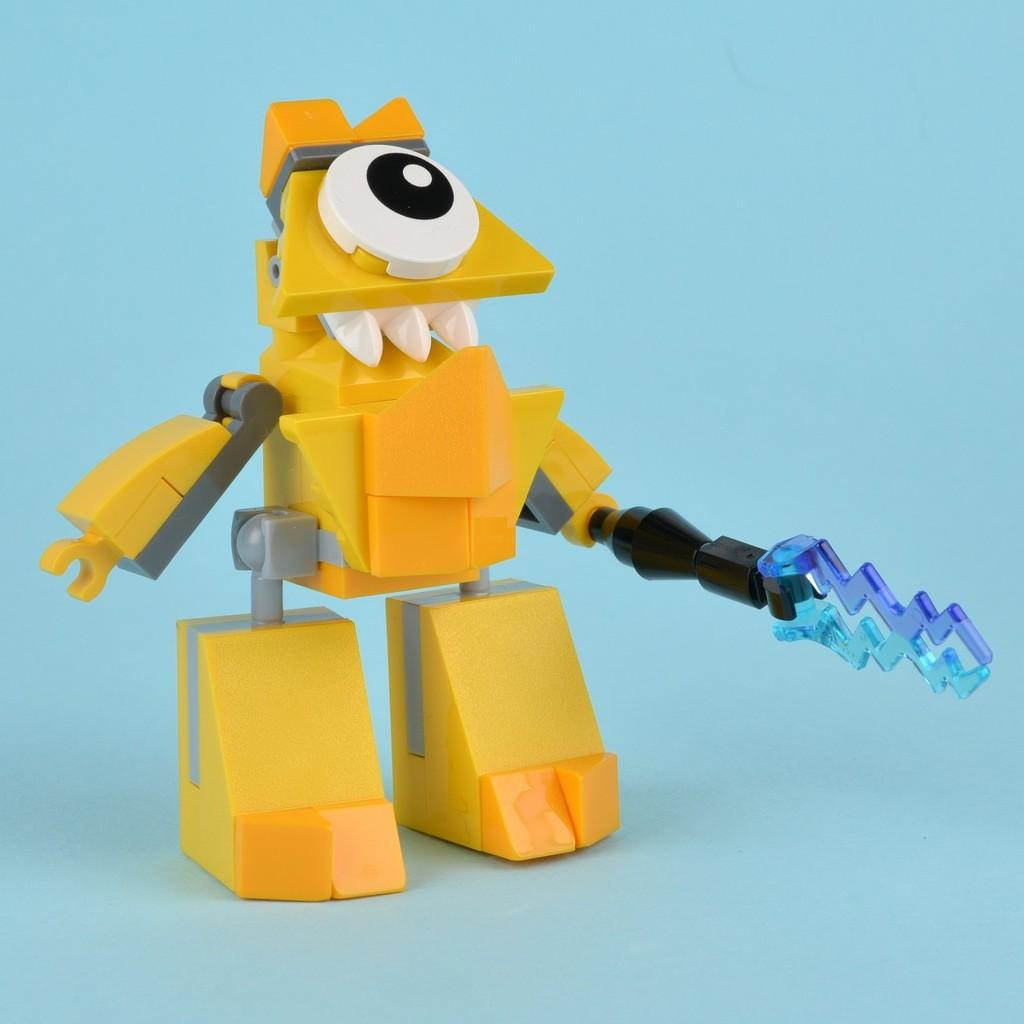What is the main subject in the center of the image? There is a yellow color toy in the center of the image. What is the toy holding in its hands? The toy is holding an object. What is the position of the toy in the image? The toy is standing. What color is the background of the image? The background of the image is blue in color. Can you see any force being applied to the toy in the image? There is no indication of force being applied to the toy in the image. Is there a playground visible in the image? There is no playground present in the image. 